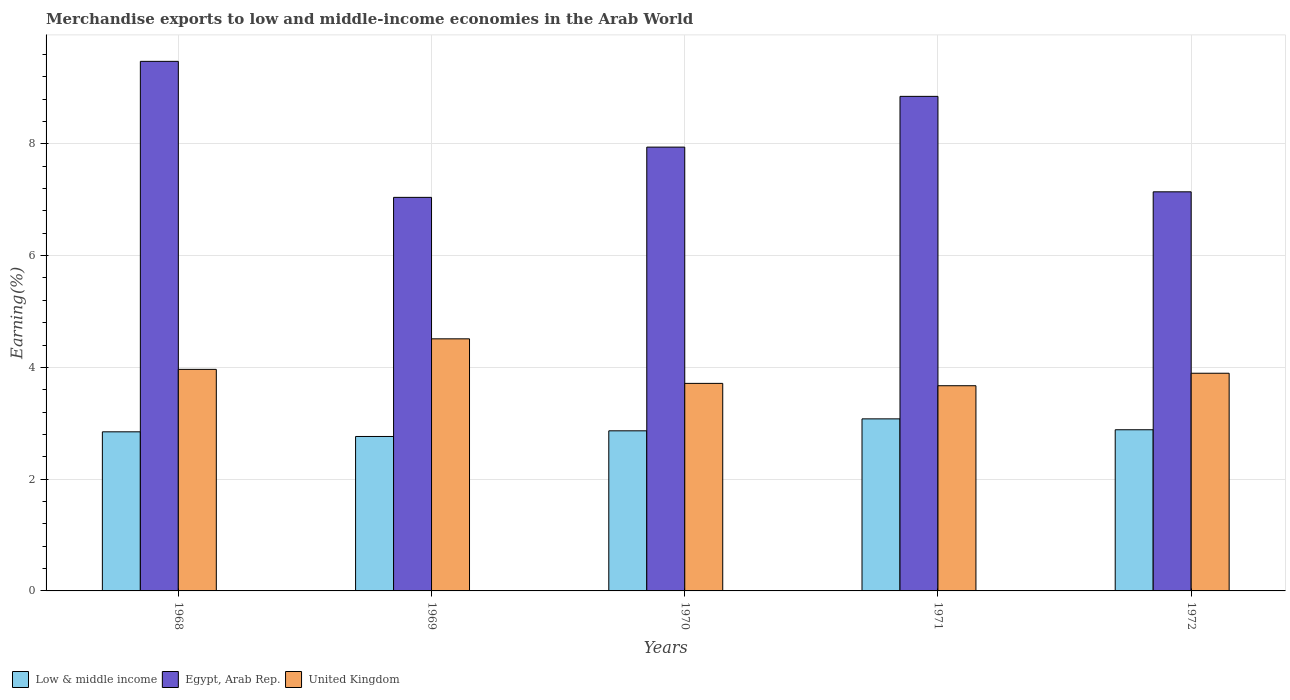How many bars are there on the 1st tick from the left?
Provide a short and direct response. 3. How many bars are there on the 5th tick from the right?
Ensure brevity in your answer.  3. What is the label of the 5th group of bars from the left?
Ensure brevity in your answer.  1972. What is the percentage of amount earned from merchandise exports in United Kingdom in 1969?
Offer a terse response. 4.51. Across all years, what is the maximum percentage of amount earned from merchandise exports in Low & middle income?
Make the answer very short. 3.08. Across all years, what is the minimum percentage of amount earned from merchandise exports in Low & middle income?
Keep it short and to the point. 2.76. In which year was the percentage of amount earned from merchandise exports in Egypt, Arab Rep. maximum?
Keep it short and to the point. 1968. In which year was the percentage of amount earned from merchandise exports in Low & middle income minimum?
Your answer should be compact. 1969. What is the total percentage of amount earned from merchandise exports in United Kingdom in the graph?
Provide a succinct answer. 19.75. What is the difference between the percentage of amount earned from merchandise exports in United Kingdom in 1969 and that in 1970?
Keep it short and to the point. 0.8. What is the difference between the percentage of amount earned from merchandise exports in United Kingdom in 1969 and the percentage of amount earned from merchandise exports in Low & middle income in 1971?
Your answer should be compact. 1.43. What is the average percentage of amount earned from merchandise exports in Egypt, Arab Rep. per year?
Give a very brief answer. 8.09. In the year 1969, what is the difference between the percentage of amount earned from merchandise exports in Egypt, Arab Rep. and percentage of amount earned from merchandise exports in Low & middle income?
Your response must be concise. 4.28. What is the ratio of the percentage of amount earned from merchandise exports in Egypt, Arab Rep. in 1969 to that in 1971?
Make the answer very short. 0.8. Is the difference between the percentage of amount earned from merchandise exports in Egypt, Arab Rep. in 1968 and 1971 greater than the difference between the percentage of amount earned from merchandise exports in Low & middle income in 1968 and 1971?
Make the answer very short. Yes. What is the difference between the highest and the second highest percentage of amount earned from merchandise exports in Low & middle income?
Provide a short and direct response. 0.19. What is the difference between the highest and the lowest percentage of amount earned from merchandise exports in United Kingdom?
Your answer should be very brief. 0.84. What does the 1st bar from the left in 1971 represents?
Offer a terse response. Low & middle income. What does the 1st bar from the right in 1972 represents?
Provide a short and direct response. United Kingdom. Is it the case that in every year, the sum of the percentage of amount earned from merchandise exports in Egypt, Arab Rep. and percentage of amount earned from merchandise exports in United Kingdom is greater than the percentage of amount earned from merchandise exports in Low & middle income?
Your response must be concise. Yes. How many bars are there?
Keep it short and to the point. 15. Are all the bars in the graph horizontal?
Make the answer very short. No. How many years are there in the graph?
Your answer should be compact. 5. Are the values on the major ticks of Y-axis written in scientific E-notation?
Ensure brevity in your answer.  No. Where does the legend appear in the graph?
Your response must be concise. Bottom left. How are the legend labels stacked?
Give a very brief answer. Horizontal. What is the title of the graph?
Provide a succinct answer. Merchandise exports to low and middle-income economies in the Arab World. Does "Cyprus" appear as one of the legend labels in the graph?
Keep it short and to the point. No. What is the label or title of the Y-axis?
Make the answer very short. Earning(%). What is the Earning(%) of Low & middle income in 1968?
Ensure brevity in your answer.  2.85. What is the Earning(%) of Egypt, Arab Rep. in 1968?
Make the answer very short. 9.48. What is the Earning(%) of United Kingdom in 1968?
Your response must be concise. 3.96. What is the Earning(%) in Low & middle income in 1969?
Your response must be concise. 2.76. What is the Earning(%) of Egypt, Arab Rep. in 1969?
Keep it short and to the point. 7.04. What is the Earning(%) in United Kingdom in 1969?
Ensure brevity in your answer.  4.51. What is the Earning(%) of Low & middle income in 1970?
Provide a succinct answer. 2.86. What is the Earning(%) of Egypt, Arab Rep. in 1970?
Your answer should be compact. 7.94. What is the Earning(%) in United Kingdom in 1970?
Offer a very short reply. 3.71. What is the Earning(%) in Low & middle income in 1971?
Keep it short and to the point. 3.08. What is the Earning(%) of Egypt, Arab Rep. in 1971?
Ensure brevity in your answer.  8.85. What is the Earning(%) of United Kingdom in 1971?
Your response must be concise. 3.67. What is the Earning(%) of Low & middle income in 1972?
Your answer should be compact. 2.88. What is the Earning(%) in Egypt, Arab Rep. in 1972?
Offer a terse response. 7.14. What is the Earning(%) of United Kingdom in 1972?
Provide a short and direct response. 3.89. Across all years, what is the maximum Earning(%) in Low & middle income?
Give a very brief answer. 3.08. Across all years, what is the maximum Earning(%) of Egypt, Arab Rep.?
Provide a succinct answer. 9.48. Across all years, what is the maximum Earning(%) of United Kingdom?
Offer a very short reply. 4.51. Across all years, what is the minimum Earning(%) of Low & middle income?
Ensure brevity in your answer.  2.76. Across all years, what is the minimum Earning(%) in Egypt, Arab Rep.?
Keep it short and to the point. 7.04. Across all years, what is the minimum Earning(%) in United Kingdom?
Give a very brief answer. 3.67. What is the total Earning(%) in Low & middle income in the graph?
Offer a very short reply. 14.44. What is the total Earning(%) in Egypt, Arab Rep. in the graph?
Your response must be concise. 40.45. What is the total Earning(%) in United Kingdom in the graph?
Give a very brief answer. 19.75. What is the difference between the Earning(%) of Low & middle income in 1968 and that in 1969?
Your response must be concise. 0.08. What is the difference between the Earning(%) in Egypt, Arab Rep. in 1968 and that in 1969?
Your response must be concise. 2.43. What is the difference between the Earning(%) of United Kingdom in 1968 and that in 1969?
Offer a terse response. -0.55. What is the difference between the Earning(%) of Low & middle income in 1968 and that in 1970?
Provide a succinct answer. -0.02. What is the difference between the Earning(%) of Egypt, Arab Rep. in 1968 and that in 1970?
Keep it short and to the point. 1.53. What is the difference between the Earning(%) of United Kingdom in 1968 and that in 1970?
Offer a very short reply. 0.25. What is the difference between the Earning(%) in Low & middle income in 1968 and that in 1971?
Your answer should be very brief. -0.23. What is the difference between the Earning(%) in Egypt, Arab Rep. in 1968 and that in 1971?
Provide a short and direct response. 0.63. What is the difference between the Earning(%) of United Kingdom in 1968 and that in 1971?
Ensure brevity in your answer.  0.29. What is the difference between the Earning(%) of Low & middle income in 1968 and that in 1972?
Provide a short and direct response. -0.04. What is the difference between the Earning(%) in Egypt, Arab Rep. in 1968 and that in 1972?
Your answer should be compact. 2.33. What is the difference between the Earning(%) in United Kingdom in 1968 and that in 1972?
Provide a short and direct response. 0.07. What is the difference between the Earning(%) in Low & middle income in 1969 and that in 1970?
Offer a very short reply. -0.1. What is the difference between the Earning(%) in Egypt, Arab Rep. in 1969 and that in 1970?
Provide a short and direct response. -0.9. What is the difference between the Earning(%) of United Kingdom in 1969 and that in 1970?
Offer a very short reply. 0.8. What is the difference between the Earning(%) of Low & middle income in 1969 and that in 1971?
Offer a very short reply. -0.32. What is the difference between the Earning(%) of Egypt, Arab Rep. in 1969 and that in 1971?
Ensure brevity in your answer.  -1.81. What is the difference between the Earning(%) in United Kingdom in 1969 and that in 1971?
Your answer should be very brief. 0.84. What is the difference between the Earning(%) of Low & middle income in 1969 and that in 1972?
Make the answer very short. -0.12. What is the difference between the Earning(%) in Egypt, Arab Rep. in 1969 and that in 1972?
Your response must be concise. -0.1. What is the difference between the Earning(%) of United Kingdom in 1969 and that in 1972?
Offer a terse response. 0.62. What is the difference between the Earning(%) in Low & middle income in 1970 and that in 1971?
Your answer should be compact. -0.21. What is the difference between the Earning(%) in Egypt, Arab Rep. in 1970 and that in 1971?
Make the answer very short. -0.91. What is the difference between the Earning(%) in United Kingdom in 1970 and that in 1971?
Keep it short and to the point. 0.04. What is the difference between the Earning(%) of Low & middle income in 1970 and that in 1972?
Offer a very short reply. -0.02. What is the difference between the Earning(%) in Egypt, Arab Rep. in 1970 and that in 1972?
Provide a short and direct response. 0.8. What is the difference between the Earning(%) in United Kingdom in 1970 and that in 1972?
Keep it short and to the point. -0.18. What is the difference between the Earning(%) of Low & middle income in 1971 and that in 1972?
Give a very brief answer. 0.19. What is the difference between the Earning(%) in Egypt, Arab Rep. in 1971 and that in 1972?
Your response must be concise. 1.71. What is the difference between the Earning(%) in United Kingdom in 1971 and that in 1972?
Your answer should be very brief. -0.22. What is the difference between the Earning(%) of Low & middle income in 1968 and the Earning(%) of Egypt, Arab Rep. in 1969?
Provide a short and direct response. -4.19. What is the difference between the Earning(%) of Low & middle income in 1968 and the Earning(%) of United Kingdom in 1969?
Give a very brief answer. -1.66. What is the difference between the Earning(%) of Egypt, Arab Rep. in 1968 and the Earning(%) of United Kingdom in 1969?
Provide a succinct answer. 4.96. What is the difference between the Earning(%) of Low & middle income in 1968 and the Earning(%) of Egypt, Arab Rep. in 1970?
Ensure brevity in your answer.  -5.09. What is the difference between the Earning(%) of Low & middle income in 1968 and the Earning(%) of United Kingdom in 1970?
Your answer should be very brief. -0.87. What is the difference between the Earning(%) of Egypt, Arab Rep. in 1968 and the Earning(%) of United Kingdom in 1970?
Give a very brief answer. 5.76. What is the difference between the Earning(%) of Low & middle income in 1968 and the Earning(%) of Egypt, Arab Rep. in 1971?
Provide a short and direct response. -6. What is the difference between the Earning(%) of Low & middle income in 1968 and the Earning(%) of United Kingdom in 1971?
Your answer should be compact. -0.82. What is the difference between the Earning(%) of Egypt, Arab Rep. in 1968 and the Earning(%) of United Kingdom in 1971?
Provide a short and direct response. 5.8. What is the difference between the Earning(%) in Low & middle income in 1968 and the Earning(%) in Egypt, Arab Rep. in 1972?
Provide a succinct answer. -4.29. What is the difference between the Earning(%) of Low & middle income in 1968 and the Earning(%) of United Kingdom in 1972?
Provide a succinct answer. -1.05. What is the difference between the Earning(%) of Egypt, Arab Rep. in 1968 and the Earning(%) of United Kingdom in 1972?
Give a very brief answer. 5.58. What is the difference between the Earning(%) of Low & middle income in 1969 and the Earning(%) of Egypt, Arab Rep. in 1970?
Offer a very short reply. -5.18. What is the difference between the Earning(%) in Low & middle income in 1969 and the Earning(%) in United Kingdom in 1970?
Give a very brief answer. -0.95. What is the difference between the Earning(%) of Egypt, Arab Rep. in 1969 and the Earning(%) of United Kingdom in 1970?
Offer a very short reply. 3.33. What is the difference between the Earning(%) of Low & middle income in 1969 and the Earning(%) of Egypt, Arab Rep. in 1971?
Keep it short and to the point. -6.09. What is the difference between the Earning(%) of Low & middle income in 1969 and the Earning(%) of United Kingdom in 1971?
Keep it short and to the point. -0.91. What is the difference between the Earning(%) of Egypt, Arab Rep. in 1969 and the Earning(%) of United Kingdom in 1971?
Give a very brief answer. 3.37. What is the difference between the Earning(%) of Low & middle income in 1969 and the Earning(%) of Egypt, Arab Rep. in 1972?
Offer a very short reply. -4.38. What is the difference between the Earning(%) in Low & middle income in 1969 and the Earning(%) in United Kingdom in 1972?
Your answer should be very brief. -1.13. What is the difference between the Earning(%) of Egypt, Arab Rep. in 1969 and the Earning(%) of United Kingdom in 1972?
Provide a succinct answer. 3.15. What is the difference between the Earning(%) of Low & middle income in 1970 and the Earning(%) of Egypt, Arab Rep. in 1971?
Provide a short and direct response. -5.98. What is the difference between the Earning(%) of Low & middle income in 1970 and the Earning(%) of United Kingdom in 1971?
Your response must be concise. -0.81. What is the difference between the Earning(%) in Egypt, Arab Rep. in 1970 and the Earning(%) in United Kingdom in 1971?
Offer a very short reply. 4.27. What is the difference between the Earning(%) in Low & middle income in 1970 and the Earning(%) in Egypt, Arab Rep. in 1972?
Your answer should be very brief. -4.28. What is the difference between the Earning(%) in Low & middle income in 1970 and the Earning(%) in United Kingdom in 1972?
Provide a short and direct response. -1.03. What is the difference between the Earning(%) of Egypt, Arab Rep. in 1970 and the Earning(%) of United Kingdom in 1972?
Offer a terse response. 4.05. What is the difference between the Earning(%) of Low & middle income in 1971 and the Earning(%) of Egypt, Arab Rep. in 1972?
Give a very brief answer. -4.06. What is the difference between the Earning(%) in Low & middle income in 1971 and the Earning(%) in United Kingdom in 1972?
Offer a very short reply. -0.82. What is the difference between the Earning(%) of Egypt, Arab Rep. in 1971 and the Earning(%) of United Kingdom in 1972?
Ensure brevity in your answer.  4.95. What is the average Earning(%) of Low & middle income per year?
Provide a succinct answer. 2.89. What is the average Earning(%) in Egypt, Arab Rep. per year?
Offer a very short reply. 8.09. What is the average Earning(%) of United Kingdom per year?
Ensure brevity in your answer.  3.95. In the year 1968, what is the difference between the Earning(%) in Low & middle income and Earning(%) in Egypt, Arab Rep.?
Your answer should be very brief. -6.63. In the year 1968, what is the difference between the Earning(%) of Low & middle income and Earning(%) of United Kingdom?
Offer a terse response. -1.12. In the year 1968, what is the difference between the Earning(%) in Egypt, Arab Rep. and Earning(%) in United Kingdom?
Offer a terse response. 5.51. In the year 1969, what is the difference between the Earning(%) in Low & middle income and Earning(%) in Egypt, Arab Rep.?
Your response must be concise. -4.28. In the year 1969, what is the difference between the Earning(%) in Low & middle income and Earning(%) in United Kingdom?
Offer a very short reply. -1.75. In the year 1969, what is the difference between the Earning(%) of Egypt, Arab Rep. and Earning(%) of United Kingdom?
Make the answer very short. 2.53. In the year 1970, what is the difference between the Earning(%) of Low & middle income and Earning(%) of Egypt, Arab Rep.?
Offer a terse response. -5.08. In the year 1970, what is the difference between the Earning(%) in Low & middle income and Earning(%) in United Kingdom?
Provide a short and direct response. -0.85. In the year 1970, what is the difference between the Earning(%) of Egypt, Arab Rep. and Earning(%) of United Kingdom?
Make the answer very short. 4.23. In the year 1971, what is the difference between the Earning(%) in Low & middle income and Earning(%) in Egypt, Arab Rep.?
Your answer should be very brief. -5.77. In the year 1971, what is the difference between the Earning(%) in Low & middle income and Earning(%) in United Kingdom?
Your response must be concise. -0.59. In the year 1971, what is the difference between the Earning(%) of Egypt, Arab Rep. and Earning(%) of United Kingdom?
Give a very brief answer. 5.18. In the year 1972, what is the difference between the Earning(%) of Low & middle income and Earning(%) of Egypt, Arab Rep.?
Keep it short and to the point. -4.26. In the year 1972, what is the difference between the Earning(%) in Low & middle income and Earning(%) in United Kingdom?
Provide a succinct answer. -1.01. In the year 1972, what is the difference between the Earning(%) in Egypt, Arab Rep. and Earning(%) in United Kingdom?
Make the answer very short. 3.25. What is the ratio of the Earning(%) in Low & middle income in 1968 to that in 1969?
Offer a terse response. 1.03. What is the ratio of the Earning(%) of Egypt, Arab Rep. in 1968 to that in 1969?
Provide a succinct answer. 1.35. What is the ratio of the Earning(%) of United Kingdom in 1968 to that in 1969?
Provide a succinct answer. 0.88. What is the ratio of the Earning(%) of Low & middle income in 1968 to that in 1970?
Offer a terse response. 0.99. What is the ratio of the Earning(%) in Egypt, Arab Rep. in 1968 to that in 1970?
Offer a terse response. 1.19. What is the ratio of the Earning(%) in United Kingdom in 1968 to that in 1970?
Make the answer very short. 1.07. What is the ratio of the Earning(%) of Low & middle income in 1968 to that in 1971?
Keep it short and to the point. 0.92. What is the ratio of the Earning(%) of Egypt, Arab Rep. in 1968 to that in 1971?
Your response must be concise. 1.07. What is the ratio of the Earning(%) of United Kingdom in 1968 to that in 1971?
Make the answer very short. 1.08. What is the ratio of the Earning(%) of Low & middle income in 1968 to that in 1972?
Provide a short and direct response. 0.99. What is the ratio of the Earning(%) of Egypt, Arab Rep. in 1968 to that in 1972?
Offer a very short reply. 1.33. What is the ratio of the Earning(%) of United Kingdom in 1968 to that in 1972?
Keep it short and to the point. 1.02. What is the ratio of the Earning(%) of Low & middle income in 1969 to that in 1970?
Offer a terse response. 0.96. What is the ratio of the Earning(%) of Egypt, Arab Rep. in 1969 to that in 1970?
Provide a succinct answer. 0.89. What is the ratio of the Earning(%) in United Kingdom in 1969 to that in 1970?
Make the answer very short. 1.21. What is the ratio of the Earning(%) of Low & middle income in 1969 to that in 1971?
Keep it short and to the point. 0.9. What is the ratio of the Earning(%) in Egypt, Arab Rep. in 1969 to that in 1971?
Provide a succinct answer. 0.8. What is the ratio of the Earning(%) of United Kingdom in 1969 to that in 1971?
Ensure brevity in your answer.  1.23. What is the ratio of the Earning(%) in Egypt, Arab Rep. in 1969 to that in 1972?
Your answer should be compact. 0.99. What is the ratio of the Earning(%) of United Kingdom in 1969 to that in 1972?
Provide a short and direct response. 1.16. What is the ratio of the Earning(%) in Low & middle income in 1970 to that in 1971?
Give a very brief answer. 0.93. What is the ratio of the Earning(%) in Egypt, Arab Rep. in 1970 to that in 1971?
Your answer should be compact. 0.9. What is the ratio of the Earning(%) in United Kingdom in 1970 to that in 1971?
Provide a short and direct response. 1.01. What is the ratio of the Earning(%) of Low & middle income in 1970 to that in 1972?
Keep it short and to the point. 0.99. What is the ratio of the Earning(%) of Egypt, Arab Rep. in 1970 to that in 1972?
Make the answer very short. 1.11. What is the ratio of the Earning(%) in United Kingdom in 1970 to that in 1972?
Make the answer very short. 0.95. What is the ratio of the Earning(%) in Low & middle income in 1971 to that in 1972?
Keep it short and to the point. 1.07. What is the ratio of the Earning(%) in Egypt, Arab Rep. in 1971 to that in 1972?
Give a very brief answer. 1.24. What is the ratio of the Earning(%) in United Kingdom in 1971 to that in 1972?
Ensure brevity in your answer.  0.94. What is the difference between the highest and the second highest Earning(%) of Low & middle income?
Offer a very short reply. 0.19. What is the difference between the highest and the second highest Earning(%) of Egypt, Arab Rep.?
Offer a terse response. 0.63. What is the difference between the highest and the second highest Earning(%) of United Kingdom?
Keep it short and to the point. 0.55. What is the difference between the highest and the lowest Earning(%) of Low & middle income?
Ensure brevity in your answer.  0.32. What is the difference between the highest and the lowest Earning(%) in Egypt, Arab Rep.?
Make the answer very short. 2.43. What is the difference between the highest and the lowest Earning(%) in United Kingdom?
Ensure brevity in your answer.  0.84. 